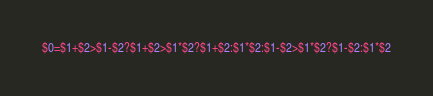Convert code to text. <code><loc_0><loc_0><loc_500><loc_500><_Awk_>$0=$1+$2>$1-$2?$1+$2>$1*$2?$1+$2:$1*$2:$1-$2>$1*$2?$1-$2:$1*$2</code> 